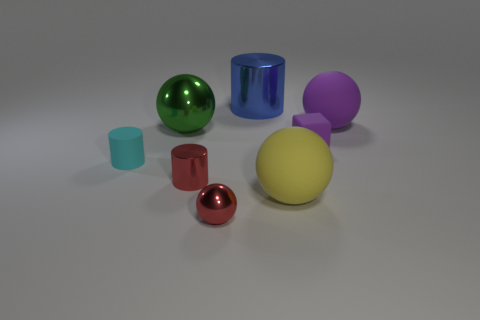Is there any other thing that has the same size as the green metallic sphere?
Ensure brevity in your answer.  Yes. Are there any large brown blocks?
Provide a short and direct response. No. Is there a yellow matte object that is behind the purple thing behind the block behind the yellow ball?
Your response must be concise. No. What number of tiny things are either purple cylinders or yellow objects?
Your answer should be compact. 0. What color is the matte cylinder that is the same size as the block?
Provide a short and direct response. Cyan. What number of large objects are to the right of the large green metal object?
Your response must be concise. 3. Are there any small red balls that have the same material as the tiny purple object?
Your answer should be compact. No. There is a object that is the same color as the small shiny ball; what shape is it?
Provide a succinct answer. Cylinder. There is a big matte sphere that is in front of the large green object; what color is it?
Your response must be concise. Yellow. Is the number of tiny metallic balls that are to the left of the big green sphere the same as the number of big spheres that are right of the small purple thing?
Your answer should be compact. No. 